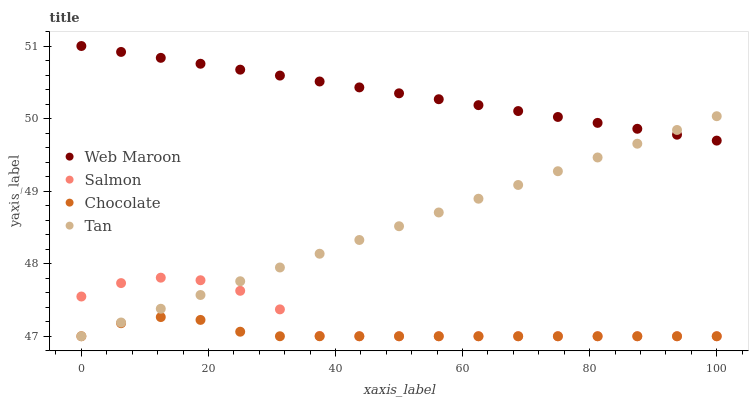Does Chocolate have the minimum area under the curve?
Answer yes or no. Yes. Does Web Maroon have the maximum area under the curve?
Answer yes or no. Yes. Does Tan have the minimum area under the curve?
Answer yes or no. No. Does Tan have the maximum area under the curve?
Answer yes or no. No. Is Tan the smoothest?
Answer yes or no. Yes. Is Salmon the roughest?
Answer yes or no. Yes. Is Web Maroon the smoothest?
Answer yes or no. No. Is Web Maroon the roughest?
Answer yes or no. No. Does Salmon have the lowest value?
Answer yes or no. Yes. Does Web Maroon have the lowest value?
Answer yes or no. No. Does Web Maroon have the highest value?
Answer yes or no. Yes. Does Tan have the highest value?
Answer yes or no. No. Is Chocolate less than Web Maroon?
Answer yes or no. Yes. Is Web Maroon greater than Salmon?
Answer yes or no. Yes. Does Salmon intersect Tan?
Answer yes or no. Yes. Is Salmon less than Tan?
Answer yes or no. No. Is Salmon greater than Tan?
Answer yes or no. No. Does Chocolate intersect Web Maroon?
Answer yes or no. No. 